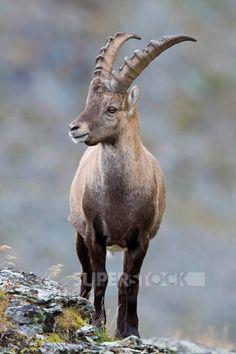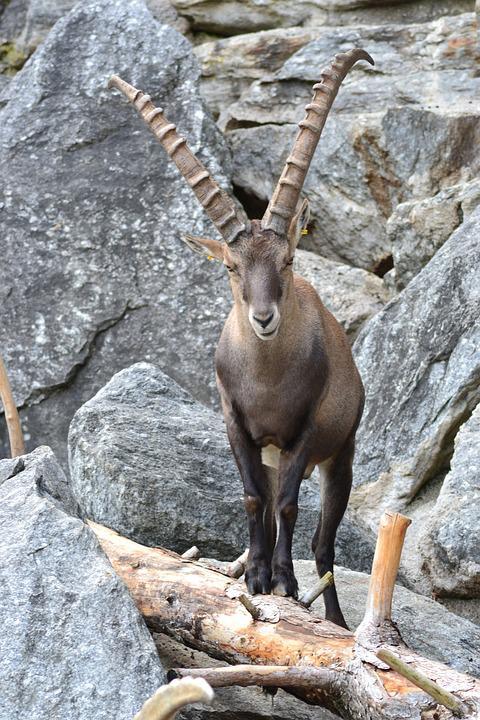The first image is the image on the left, the second image is the image on the right. For the images displayed, is the sentence "The right image contains a horned animal looking at the camera." factually correct? Answer yes or no. Yes. 